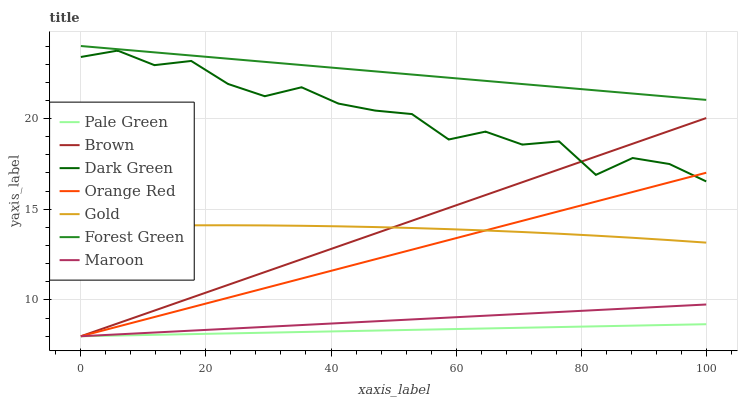Does Gold have the minimum area under the curve?
Answer yes or no. No. Does Gold have the maximum area under the curve?
Answer yes or no. No. Is Gold the smoothest?
Answer yes or no. No. Is Gold the roughest?
Answer yes or no. No. Does Gold have the lowest value?
Answer yes or no. No. Does Gold have the highest value?
Answer yes or no. No. Is Pale Green less than Gold?
Answer yes or no. Yes. Is Forest Green greater than Dark Green?
Answer yes or no. Yes. Does Pale Green intersect Gold?
Answer yes or no. No. 